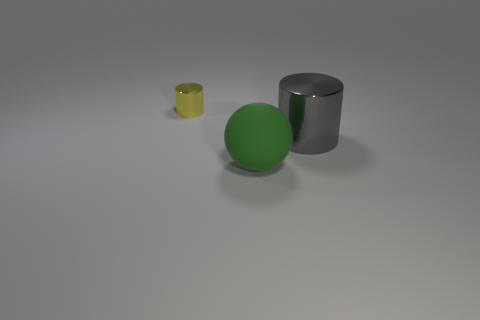What number of things are metal things left of the green rubber thing or blue spheres? There is one metal object to the left of the green rubber ball, which is a gray cylinder, and there are no blue spheres in the image. 